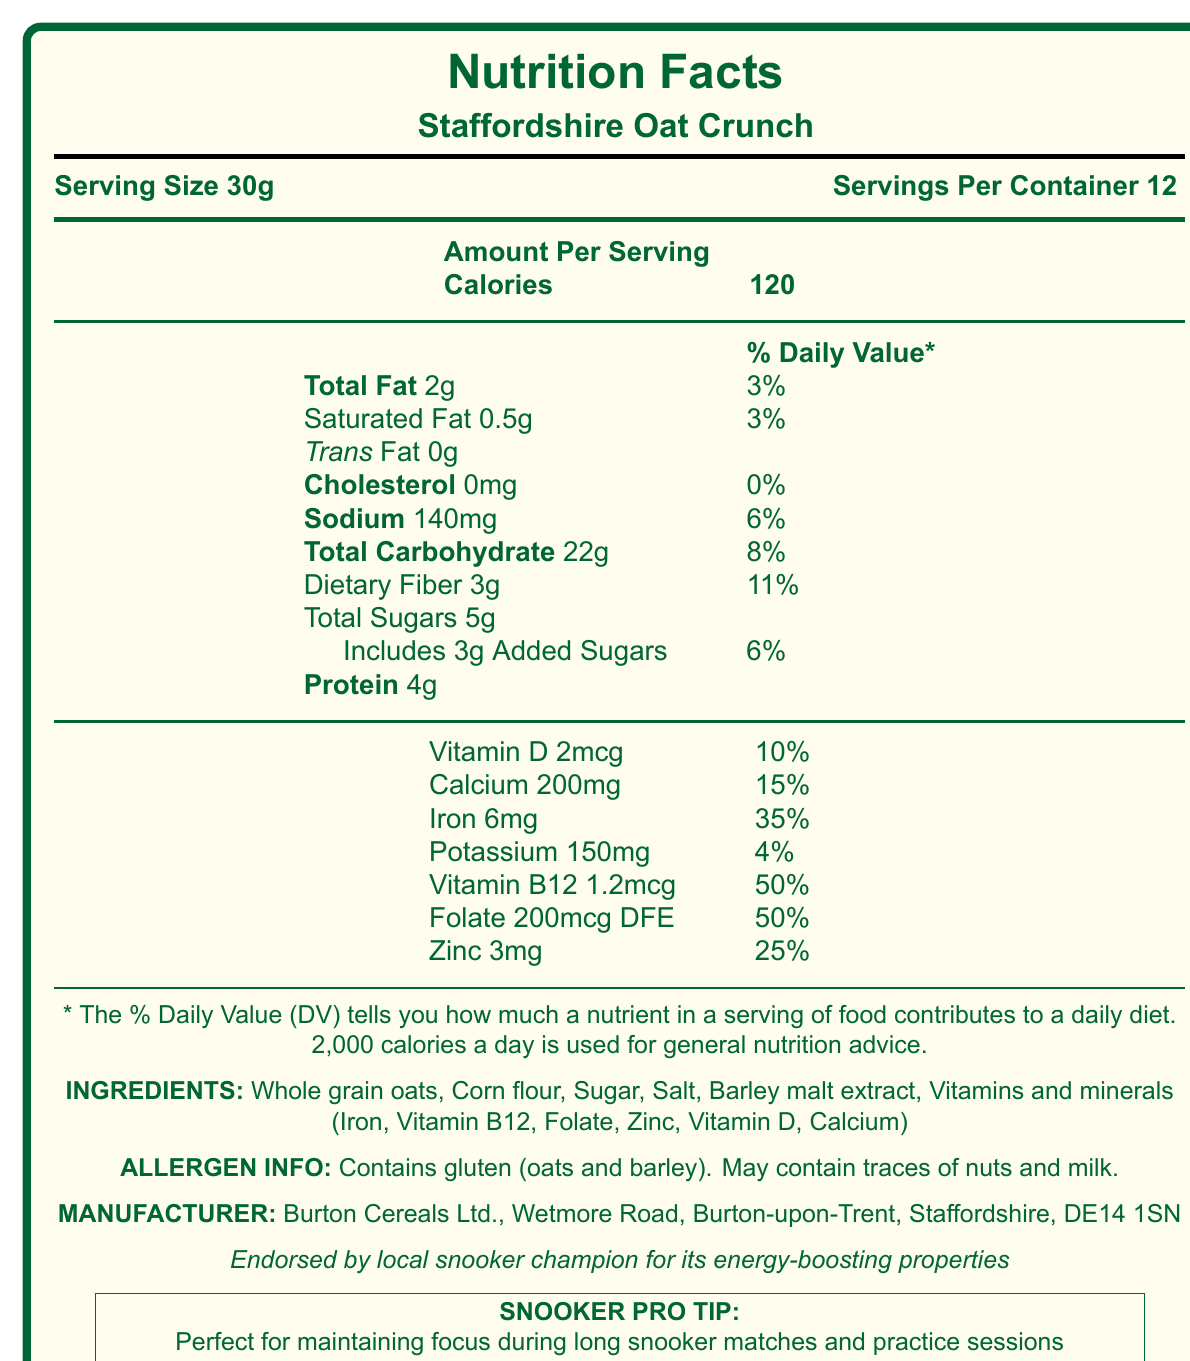what is the product name? The document lists "Staffordshire Oat Crunch" as the product name in the section for the nutrition facts label.
Answer: Staffordshire Oat Crunch what is the serving size? The document specifies "Serving Size 30g" in the nutrition information section.
Answer: 30g how many calories are in one serving? The document states that each serving contains 120 calories.
Answer: 120 what is the total fat content per serving? The document lists "Total Fat 2g" under the nutrition facts.
Answer: 2g how much dietary fiber does one serving contain? The dietary fiber content per serving is mentioned as 3g in the document.
Answer: 3g what percentage of the daily value for sodium does one serving provide? The sodium content is listed as providing 6% of the daily value.
Answer: 6% how many servings are there per container? The document mentions that there are 12 servings per container.
Answer: 12 what is the main ingredient in this cereal? A. Whole grain oats B. Corn flour C. Sugar D. Salt The first ingredient listed, "Whole grain oats," indicates it is the main ingredient.
Answer: A which vitamin has the highest daily value percentage in this product? A. Vitamin D B. Calcium C. Iron D. Vitamin B12 Vitamin B12 has the highest daily value percentage at 50%, as listed in the document.
Answer: D does the product contain any trans fat? The document states "Trans Fat 0g," indicating there is no trans fat.
Answer: No does the cereal contain gluten? The allergen information notes that the product "Contains gluten (oats and barley)."
Answer: Yes what is the exact address of the manufacturer? The document specifies "Burton Cereals Ltd., Wetmore Road, Burton-upon-Trent, Staffordshire, DE14 1SN" as the manufacturer's address.
Answer: Wetmore Road, Burton-upon-Trent, Staffordshire, DE14 1SN who endorses the cereal for its energy-boosting properties? The document mentions the endorsement by a local snooker champion for its energy-boosting properties.
Answer: A local snooker champion how is the Staffordshire Oat Crunch beneficial for snooker players? The document states it is perfect for maintaining focus during long snooker matches and practice sessions.
Answer: Maintaining focus during long matches and practice sessions is there any cholesterol in one serving of this product? The document lists "Cholesterol 0mg," indicating no cholesterol in one serving.
Answer: No what percentage of the daily value does iron contribute per serving? The document indicates that iron contributes 35% of the daily value per serving.
Answer: 35% does this cereal contain any added sugars? The document mentions "Includes 3g Added Sugars," which confirms the presence of added sugars.
Answer: Yes what is the main idea of the Nutrition Facts Label for Staffordshire Oat Crunch? The detailed description of serving size, calories, nutrient content, ingredients, allergens, and endorsements forms the central idea of the document.
Answer: The label provides detailed nutritional information for Staffordshire Oat Crunch, highlighting its low-fat, fiber-rich, and vitamin-enriched profile, suitable for providing energy and focus, especially endorsed by a local snooker champion. how many vitamins and minerals are listed on the label? The document lists Vitamin D, Calcium, Iron, Potassium, Vitamin B12, Folate, and Zinc, making a total of seven vitamins and minerals.
Answer: Seven how does the total carbohydrate content compare to the protein content per serving? The document lists the total carbohydrate content as 22g and protein as 4g per serving, showing a higher carbohydrate content.
Answer: The total carbohydrate content per serving is 22g, while the protein content is 4g, indicating that carbohydrates are more prevalent. are there any traces of nuts and milk in the product? The allergen information section of the document states that it "May contain traces of nuts and milk."
Answer: May contain traces how does the product contribute to an average 2000 calorie diet? The document explains that % Daily Value (DV) helps to understand nutrient contributions based on a 2000 calorie diet.
Answer: % Daily Value indicates how each nutrient per serving contributes to a daily diet based on 2000 calories, with various percentages listed for different nutrients. what is the manufacturer's phone number? The document does not mention any phone number for the manufacturer.
Answer: Not enough information how much Vitamin D is in one serving of the product? The document lists that one serving of Staffordshire Oat Crunch contains 2mcg of Vitamin D.
Answer: 2mcg 